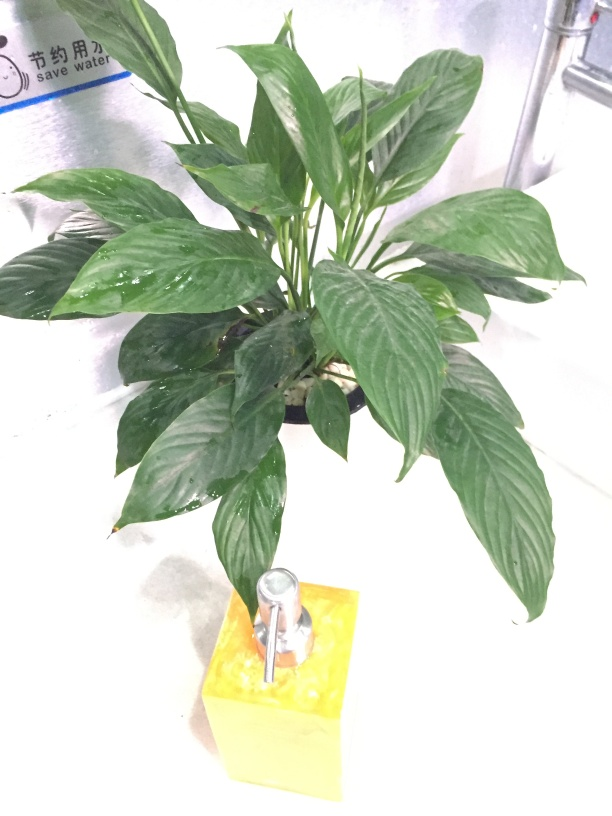What is the significance of the text in the background? The text in the background includes a message about conserving water. This suggests an environmental awareness and possibly indicates that the pictured space values sustainability. This context also complements the presence of the plant and the watering device by showcasing a theme of environmental care. 